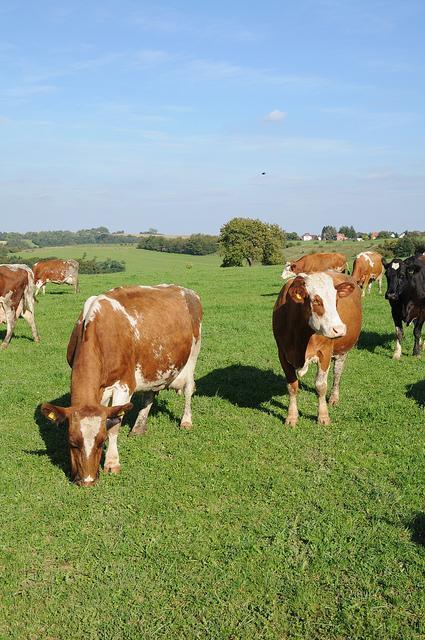How many cows are in the picture?
Give a very brief answer. 4. How many people are sitting down in the image?
Give a very brief answer. 0. 